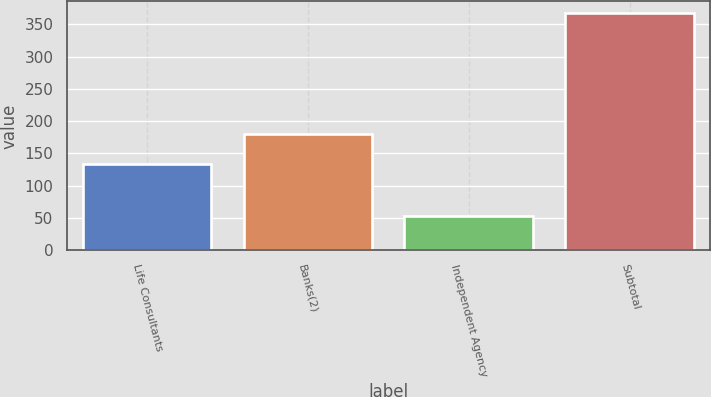Convert chart to OTSL. <chart><loc_0><loc_0><loc_500><loc_500><bar_chart><fcel>Life Consultants<fcel>Banks(2)<fcel>Independent Agency<fcel>Subtotal<nl><fcel>134<fcel>180<fcel>53<fcel>367<nl></chart> 